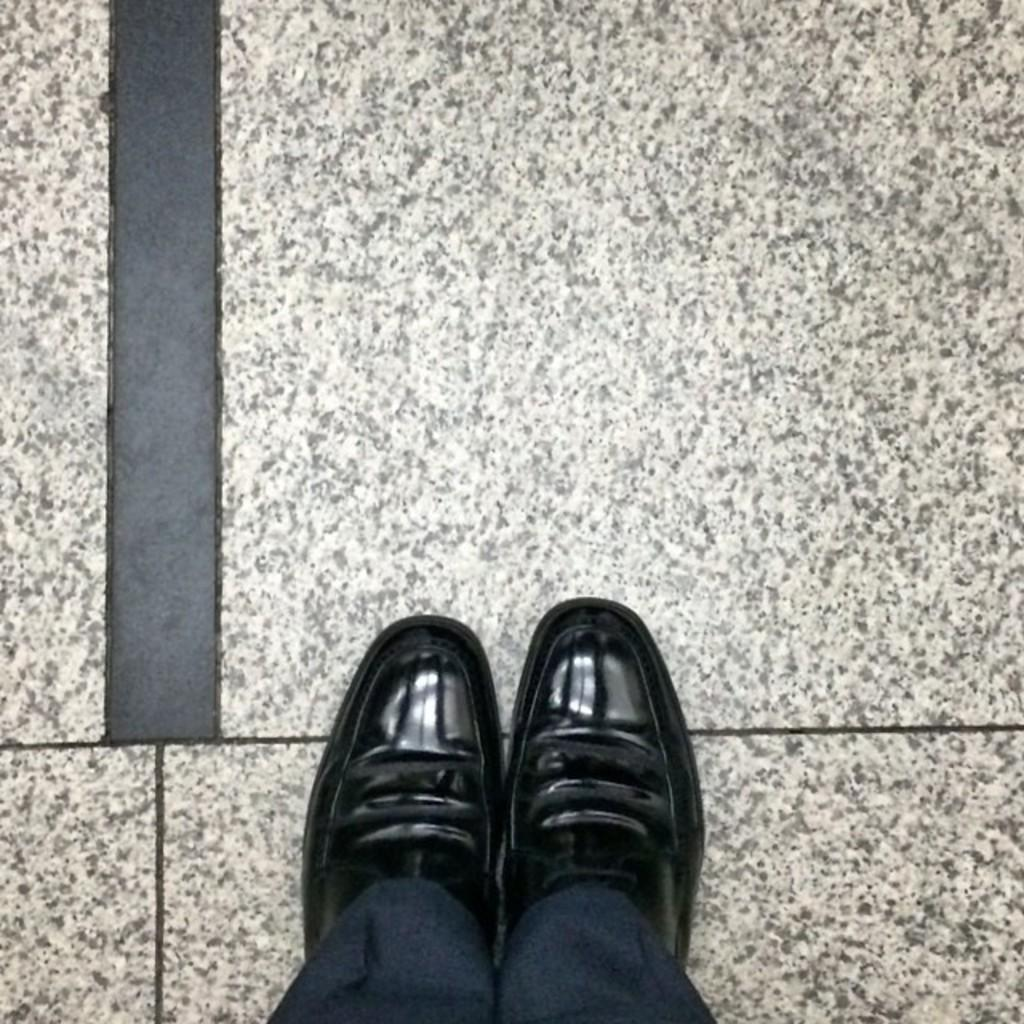What is visible at the bottom side of the image? There are two legs visible at the bottom side of the image. What type of board is being used by the doctor wearing a skirt in the image? There is no board, doctor, or skirt present in the image; only two legs are visible. 